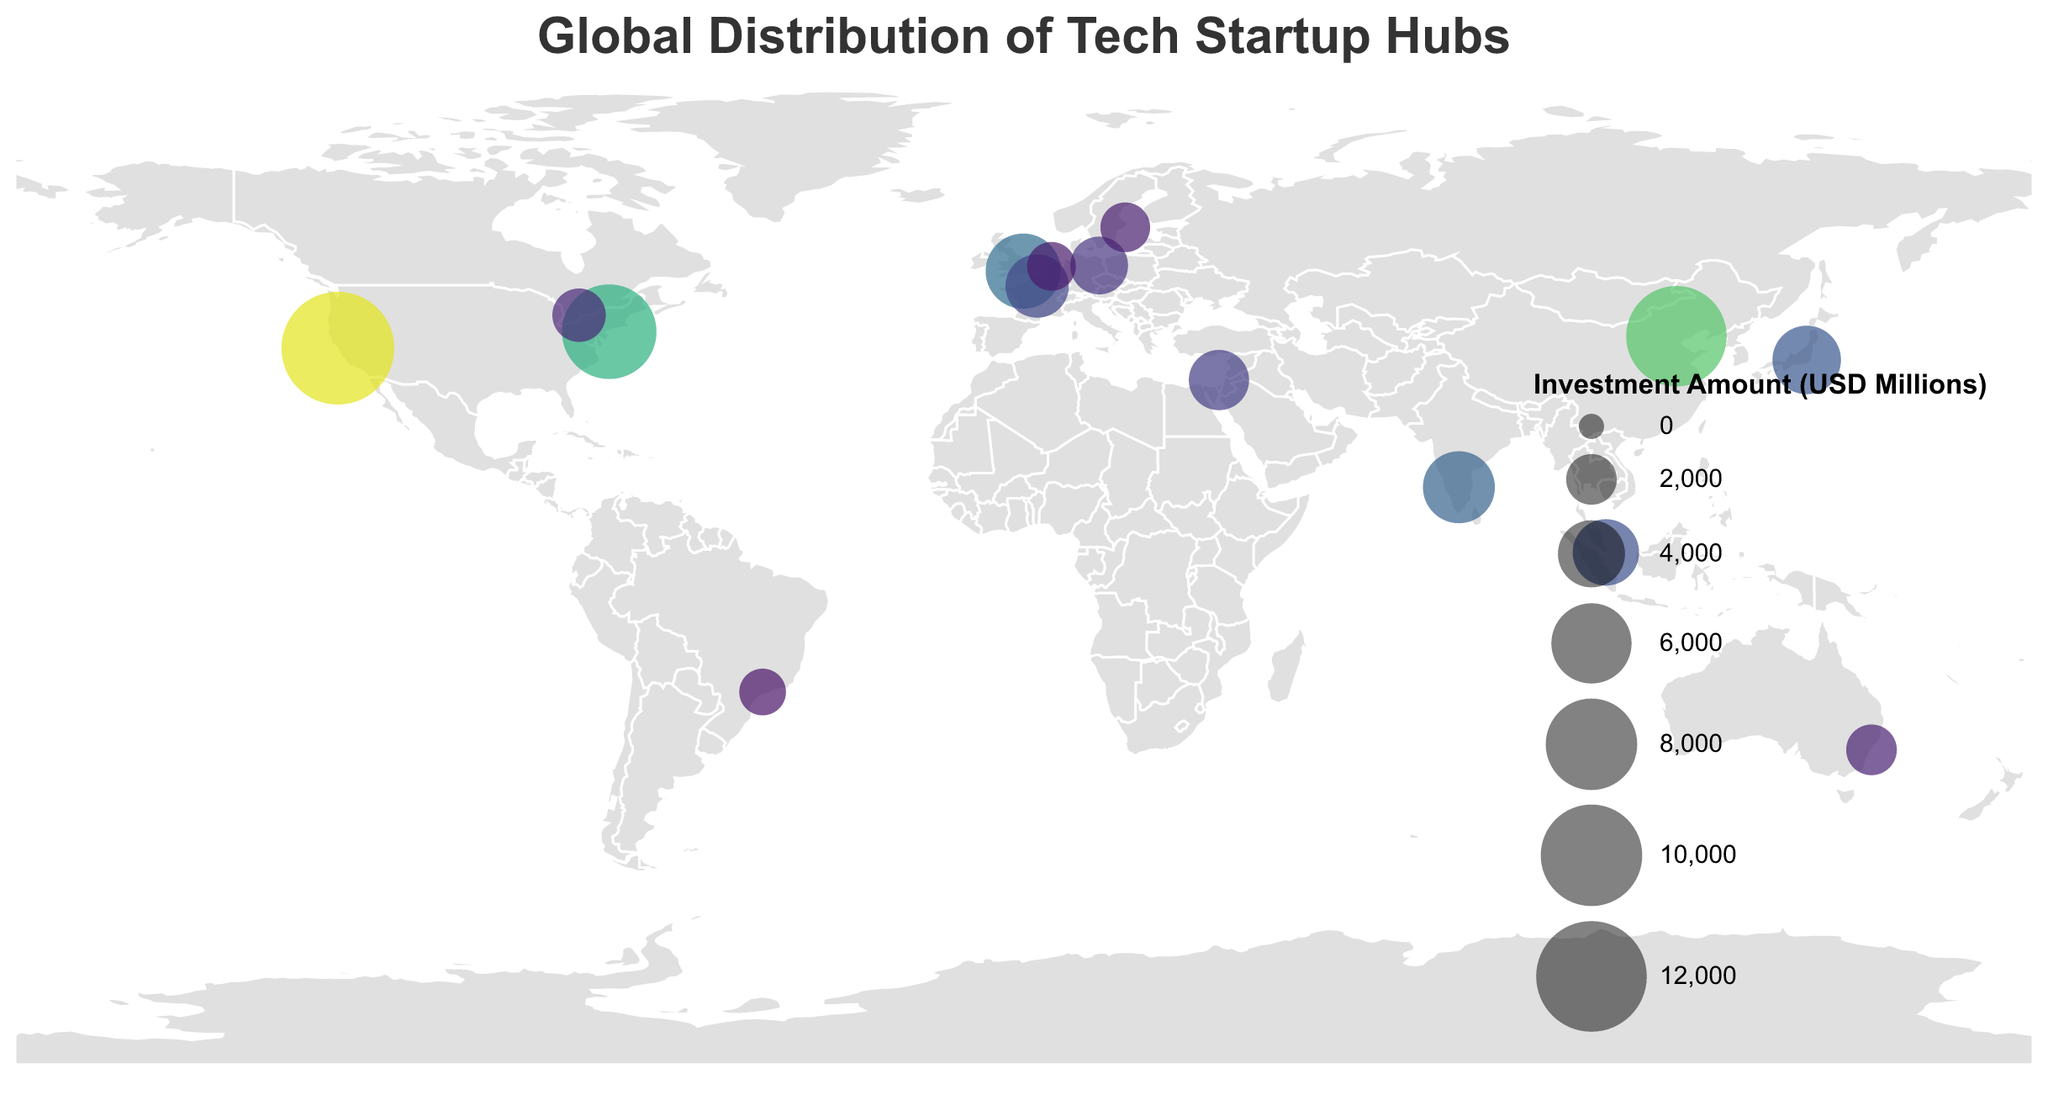What is the total investment amount for Tokyo? Tokyo is marked with a circle on the plot. The tooltip shows that the investment amount for Tokyo is 4200 million USD.
Answer: 4200 million USD Which city has the highest investment amount? The size of the circle represents the investment amount. The largest circle corresponds to San Francisco, which has an investment amount of 12500 million USD.
Answer: San Francisco How does the investment amount in London compare to New York City? The plot shows the size of the circles relative to investment amounts. London's circle (5200 million USD) is smaller than New York City's circle (8600 million USD).
Answer: London has less investment than New York City What is the average investment amount across all cities? Sum all the investment amounts and divide by the number of cities. The total is 12500 + 5200 + 9800 + 3100 + 4700 + 2800 + 3900 + 8600 + 4200 + 3500 + 1900 + 2300 + 1600 + 1800 + 2000 = 70300 million USD. There are 15 cities. Thus, the average is 70300 / 15 ≈ 4687 million USD.
Answer: 4687 million USD Which country appears more than once in the plot with different cities? Looking at the data points, the USA appears more than once with San Francisco and New York City.
Answer: USA Is there a discernible pattern in the geographical distribution of cities with high investment amounts? Cities with high investment amounts (large circles) are predominantly located in North America, Europe, and Asia. These regions have major global economic hubs.
Answer: Predominantly in North America, Europe, and Asia What is the difference in investment amounts between Beijing and Bangalore? The investment amount for Beijing is 9800 million USD and for Bangalore is 4700 million USD. The difference is 9800 - 4700 = 5100 million USD.
Answer: 5100 million USD Which city in Europe has the largest investment amount and how much is it? Of the European cities, London has the largest investment amount, shown by the largest circle in Europe at 5200 million USD.
Answer: London, 5200 million USD Name the cities with investment amounts lesser than 2000 million USD. From the data, the cities with investment amounts lesser than 2000 million USD are São Paulo (1600 million USD), Amsterdam (1800 million USD), and Stockholm (1900 million USD).
Answer: São Paulo, Amsterdam, Stockholm What’s the median investment amount for the cities represented? First, list the investment amounts in ascending order: 1600, 1800, 1900, 2000, 2300, 2800, 3100, 3500, 3900, 4200, 4700, 5200, 8600, 9800, 12500. The middle value (8th in the sequence) is 3500 million USD.
Answer: 3500 million USD 